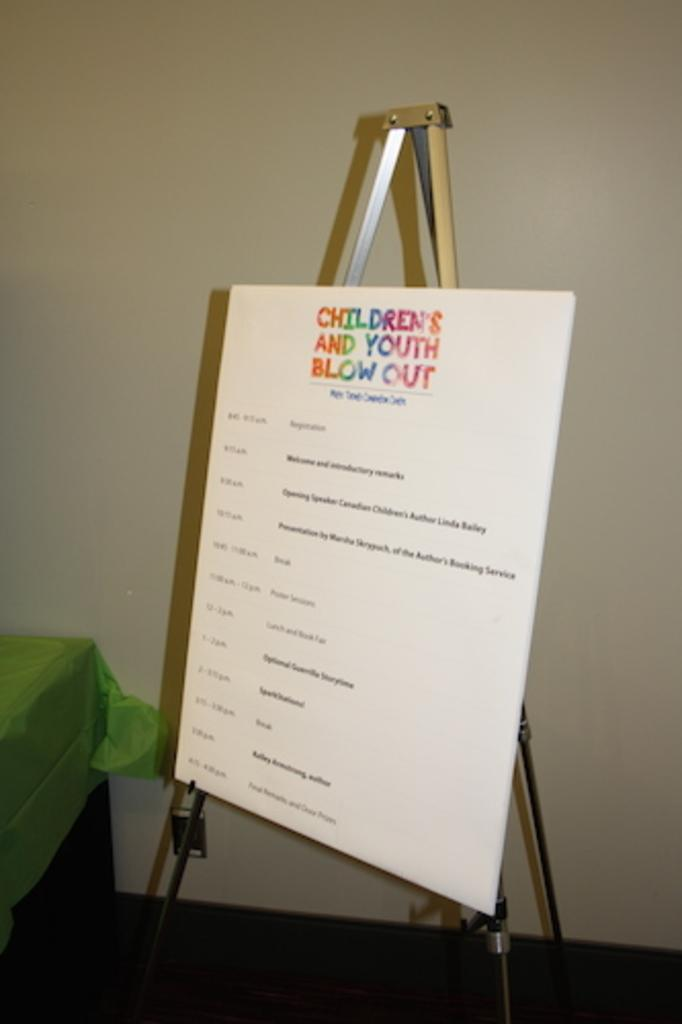<image>
Write a terse but informative summary of the picture. an easel  holding board for children's and youth blow out that lists times and events 